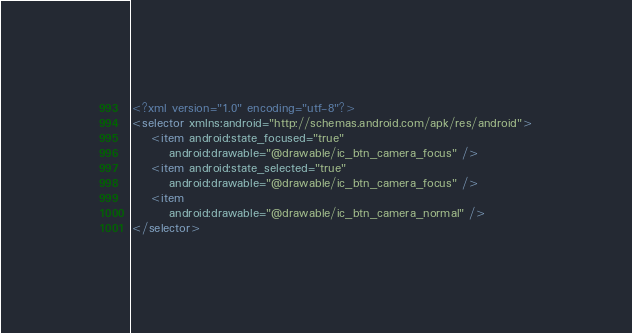Convert code to text. <code><loc_0><loc_0><loc_500><loc_500><_XML_><?xml version="1.0" encoding="utf-8"?>
<selector xmlns:android="http://schemas.android.com/apk/res/android">
    <item android:state_focused="true"
        android:drawable="@drawable/ic_btn_camera_focus" />
    <item android:state_selected="true"
        android:drawable="@drawable/ic_btn_camera_focus" />
    <item
        android:drawable="@drawable/ic_btn_camera_normal" />
</selector></code> 